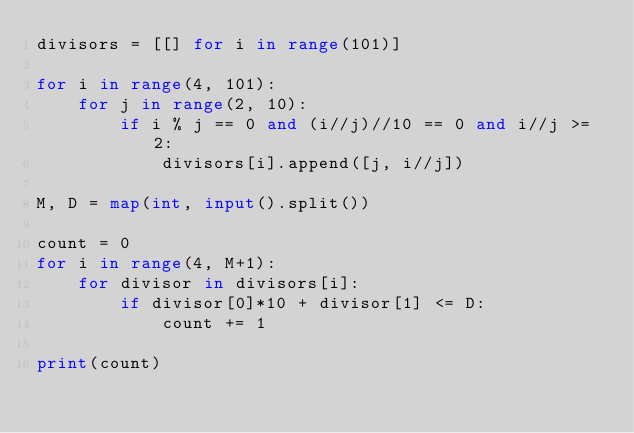Convert code to text. <code><loc_0><loc_0><loc_500><loc_500><_Python_>divisors = [[] for i in range(101)]

for i in range(4, 101):
	for j in range(2, 10):
		if i % j == 0 and (i//j)//10 == 0 and i//j >= 2:
			divisors[i].append([j, i//j])

M, D = map(int, input().split())

count = 0
for i in range(4, M+1):
	for divisor in divisors[i]:
		if divisor[0]*10 + divisor[1] <= D:
			count += 1

print(count)</code> 